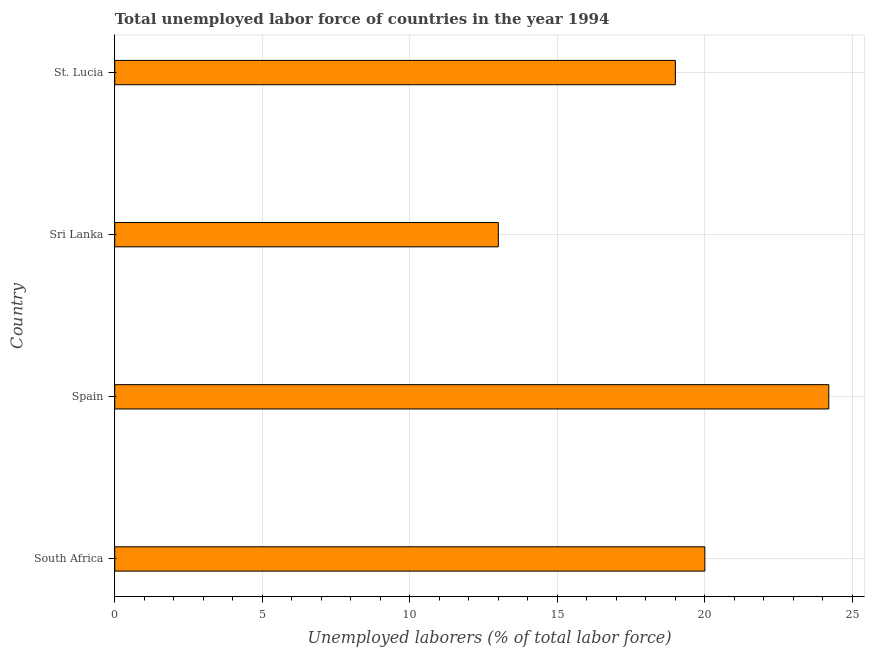Does the graph contain grids?
Offer a very short reply. Yes. What is the title of the graph?
Provide a succinct answer. Total unemployed labor force of countries in the year 1994. What is the label or title of the X-axis?
Provide a short and direct response. Unemployed laborers (% of total labor force). Across all countries, what is the maximum total unemployed labour force?
Keep it short and to the point. 24.2. In which country was the total unemployed labour force minimum?
Offer a very short reply. Sri Lanka. What is the sum of the total unemployed labour force?
Offer a terse response. 76.2. What is the difference between the total unemployed labour force in South Africa and Sri Lanka?
Ensure brevity in your answer.  7. What is the average total unemployed labour force per country?
Provide a succinct answer. 19.05. What is the median total unemployed labour force?
Your answer should be very brief. 19.5. What is the ratio of the total unemployed labour force in South Africa to that in St. Lucia?
Offer a very short reply. 1.05. What is the difference between the highest and the second highest total unemployed labour force?
Give a very brief answer. 4.2. What is the difference between the highest and the lowest total unemployed labour force?
Ensure brevity in your answer.  11.2. In how many countries, is the total unemployed labour force greater than the average total unemployed labour force taken over all countries?
Ensure brevity in your answer.  2. How many bars are there?
Keep it short and to the point. 4. Are the values on the major ticks of X-axis written in scientific E-notation?
Provide a succinct answer. No. What is the Unemployed laborers (% of total labor force) of Spain?
Your response must be concise. 24.2. What is the Unemployed laborers (% of total labor force) of St. Lucia?
Your answer should be compact. 19. What is the difference between the Unemployed laborers (% of total labor force) in South Africa and Sri Lanka?
Ensure brevity in your answer.  7. What is the difference between the Unemployed laborers (% of total labor force) in South Africa and St. Lucia?
Offer a terse response. 1. What is the difference between the Unemployed laborers (% of total labor force) in Spain and Sri Lanka?
Your response must be concise. 11.2. What is the difference between the Unemployed laborers (% of total labor force) in Spain and St. Lucia?
Your answer should be very brief. 5.2. What is the difference between the Unemployed laborers (% of total labor force) in Sri Lanka and St. Lucia?
Give a very brief answer. -6. What is the ratio of the Unemployed laborers (% of total labor force) in South Africa to that in Spain?
Ensure brevity in your answer.  0.83. What is the ratio of the Unemployed laborers (% of total labor force) in South Africa to that in Sri Lanka?
Make the answer very short. 1.54. What is the ratio of the Unemployed laborers (% of total labor force) in South Africa to that in St. Lucia?
Your response must be concise. 1.05. What is the ratio of the Unemployed laborers (% of total labor force) in Spain to that in Sri Lanka?
Keep it short and to the point. 1.86. What is the ratio of the Unemployed laborers (% of total labor force) in Spain to that in St. Lucia?
Offer a very short reply. 1.27. What is the ratio of the Unemployed laborers (% of total labor force) in Sri Lanka to that in St. Lucia?
Your answer should be compact. 0.68. 